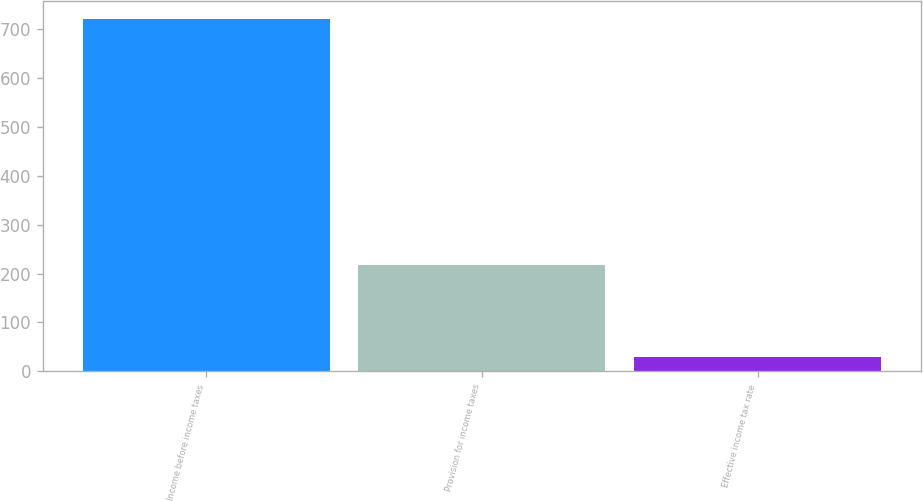Convert chart. <chart><loc_0><loc_0><loc_500><loc_500><bar_chart><fcel>Income before income taxes<fcel>Provision for income taxes<fcel>Effective income tax rate<nl><fcel>720.7<fcel>216.5<fcel>30<nl></chart> 